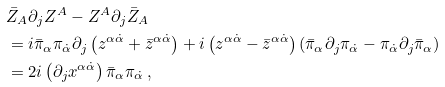Convert formula to latex. <formula><loc_0><loc_0><loc_500><loc_500>& \bar { Z } _ { A } \partial _ { j } Z ^ { A } - Z ^ { A } \partial _ { j } \bar { Z } _ { A } \\ & = i \bar { \pi } _ { \alpha } \pi _ { \dot { \alpha } } \partial _ { j } \left ( z ^ { \alpha \dot { \alpha } } + \bar { z } ^ { \alpha \dot { \alpha } } \right ) + i \left ( z ^ { \alpha \dot { \alpha } } - \bar { z } ^ { \alpha \dot { \alpha } } \right ) ( \bar { \pi } _ { \alpha } \partial _ { j } \pi _ { \dot { \alpha } } - \pi _ { \dot { \alpha } } \partial _ { j } \bar { \pi } _ { \alpha } ) \\ & = 2 i \left ( \partial _ { j } x ^ { \alpha \dot { \alpha } } \right ) \bar { \pi } _ { \alpha } \pi _ { \dot { \alpha } } \, ,</formula> 